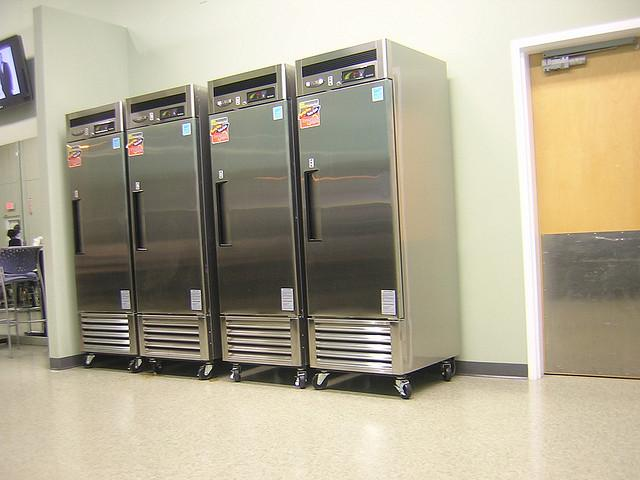Where is this scene taking place? cafeteria 